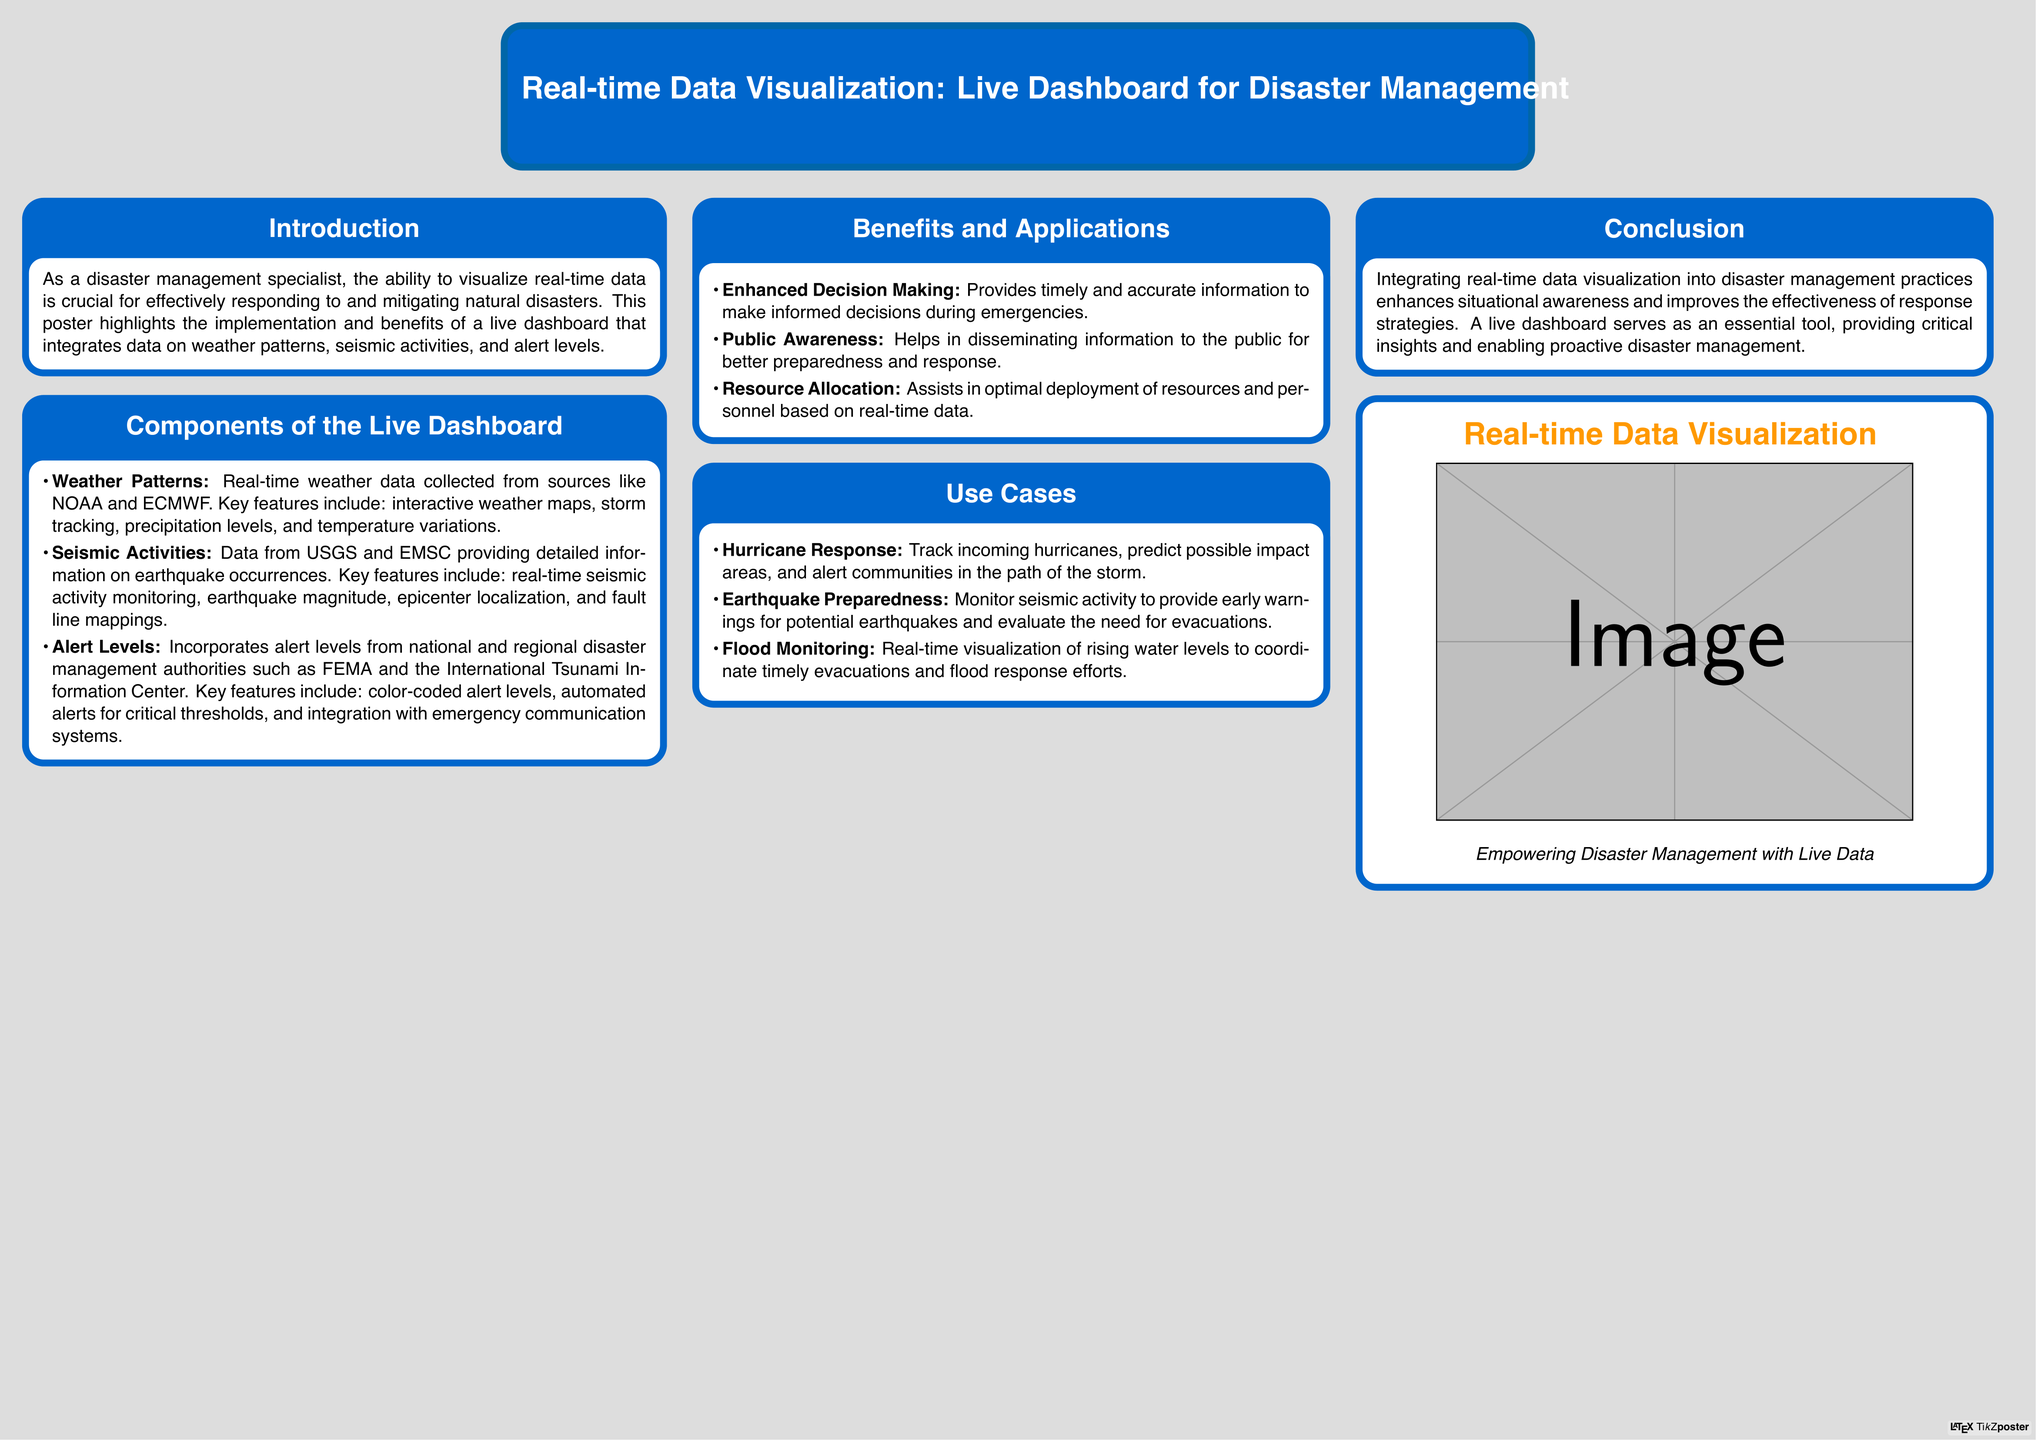What are the sources for real-time weather data? The document states that real-time weather data is collected from sources like NOAA and ECMWF.
Answer: NOAA and ECMWF What features are included in the seismic activities section? The document lists real-time seismic activity monitoring, earthquake magnitude, epicenter localization, and fault line mappings as key features.
Answer: Real-time seismic activity monitoring, earthquake magnitude, epicenter localization, fault line mappings What is one benefit of the live dashboard? The poster highlights enhanced decision making as a benefit of the live dashboard.
Answer: Enhanced decision making What type of alert levels does the dashboard incorporate? The document specifies that it incorporates alert levels from national and regional disaster management authorities.
Answer: National and regional disaster management authorities What is a use case for hurricane response? The poster suggests tracking incoming hurricanes, predicting possible impact areas, and alerting communities in the path of the storm as a use case.
Answer: Track incoming hurricanes, predict possible impact areas, alert communities How does the live dashboard enhance public awareness? The document mentions it helps in disseminating information to the public for better preparedness and response.
Answer: Disseminating information to the public What is the primary focus of the poster? The main focus of the poster is to highlight the implementation and benefits of a live dashboard for disaster management.
Answer: Implementation and benefits of a live dashboard for disaster management What is the poster's conclusion about real-time data visualization? The document concludes that integrating real-time data visualization enhances situational awareness and improves response strategies.
Answer: Enhances situational awareness and improves response strategies 